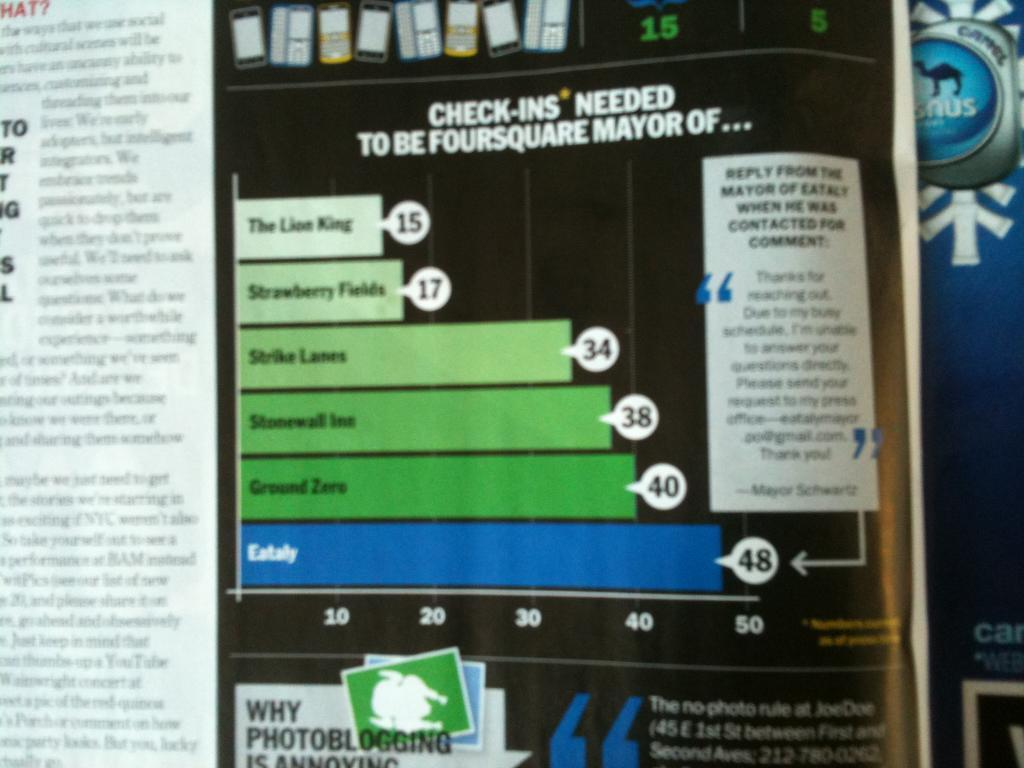What object can be seen in the image? There is a book in the image. Where is the book located? The book is placed on a surface. What can be found on the book? There is text and pictures printed on the book. How many oranges are stacked on top of the building in the image? There are no oranges or buildings present in the image; it only features a book. 